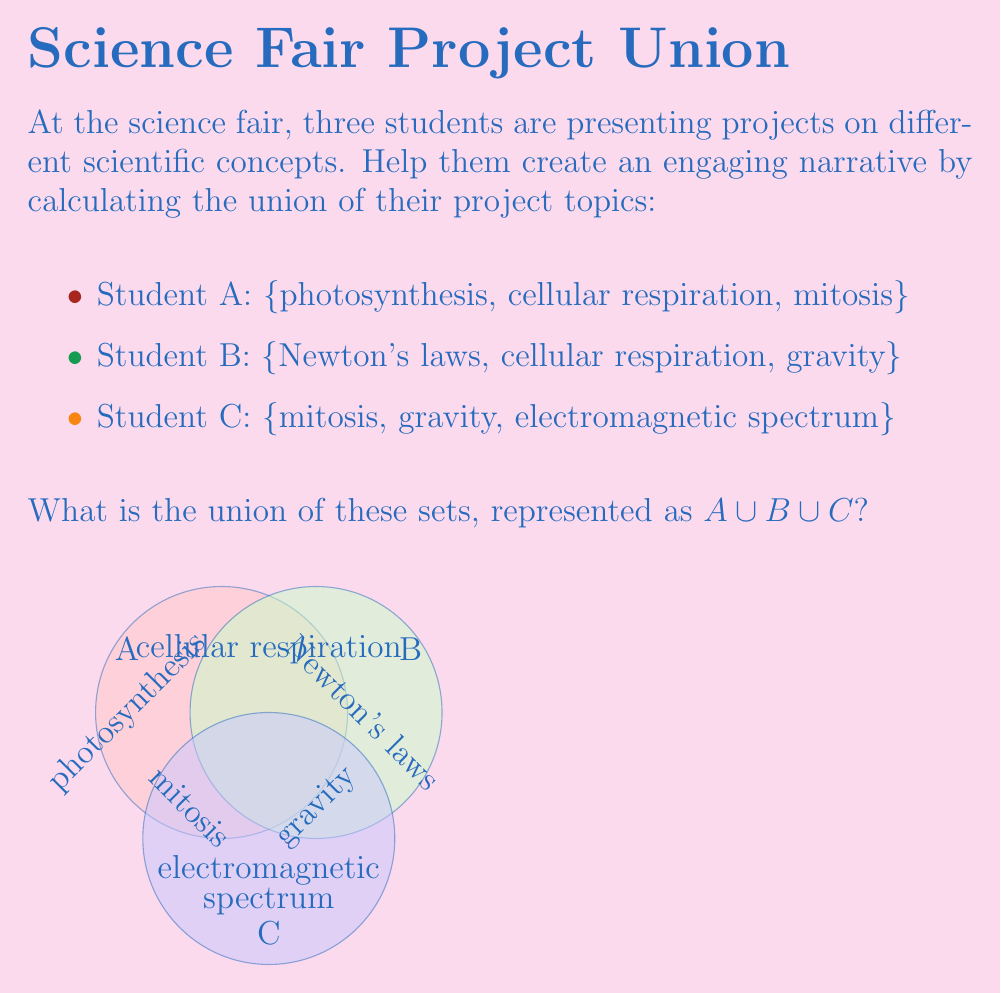Give your solution to this math problem. To find the union of these sets, we need to list all unique elements from all three sets. Let's approach this step-by-step:

1) First, let's define our sets:
   $A = \{photosynthesis, cellular respiration, mitosis\}$
   $B = \{Newton's laws, cellular respiration, gravity\}$
   $C = \{mitosis, gravity, electromagnetic spectrum\}$

2) Now, let's start building our union set by including all elements from set A:
   $A \cup B \cup C = \{photosynthesis, cellular respiration, mitosis\}$

3) Next, we add any elements from set B that are not already in our union set:
   - "Newton's laws" is not in our set, so we add it
   - "cellular respiration" is already there
   - "gravity" is not in our set, so we add it
   $A \cup B \cup C = \{photosynthesis, cellular respiration, mitosis, Newton's laws, gravity\}$

4) Finally, we add any elements from set C that are not already in our union set:
   - "mitosis" is already there
   - "gravity" is already there
   - "electromagnetic spectrum" is not in our set, so we add it
   $A \cup B \cup C = \{photosynthesis, cellular respiration, mitosis, Newton's laws, gravity, electromagnetic spectrum\}$

5) We have now included all unique elements from all three sets, giving us the complete union.
Answer: $\{photosynthesis, cellular respiration, mitosis, Newton's laws, gravity, electromagnetic spectrum\}$ 